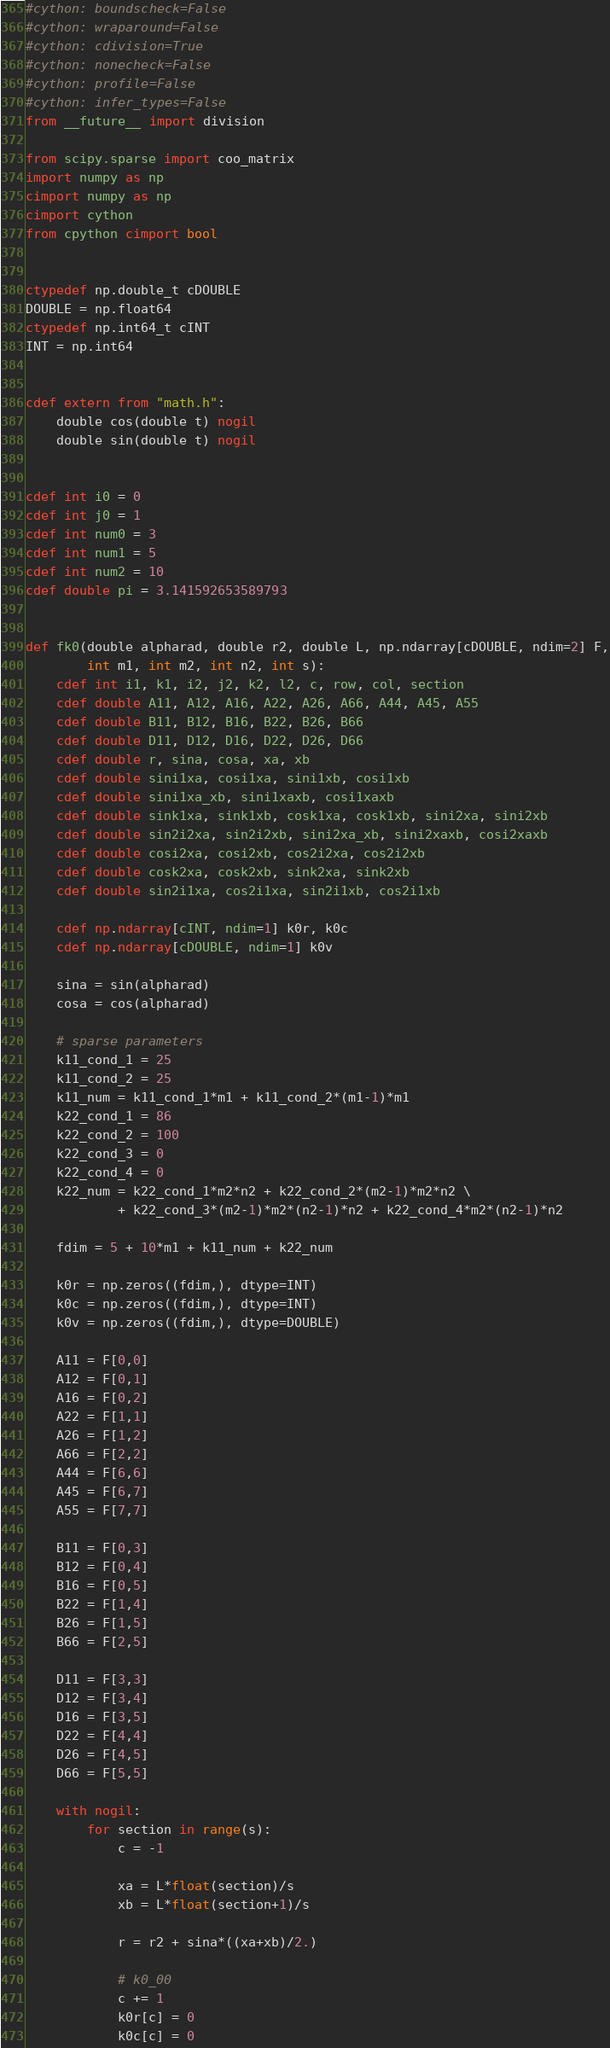Convert code to text. <code><loc_0><loc_0><loc_500><loc_500><_Cython_>#cython: boundscheck=False
#cython: wraparound=False
#cython: cdivision=True
#cython: nonecheck=False
#cython: profile=False
#cython: infer_types=False
from __future__ import division

from scipy.sparse import coo_matrix
import numpy as np
cimport numpy as np
cimport cython
from cpython cimport bool


ctypedef np.double_t cDOUBLE
DOUBLE = np.float64
ctypedef np.int64_t cINT
INT = np.int64


cdef extern from "math.h":
    double cos(double t) nogil
    double sin(double t) nogil


cdef int i0 = 0
cdef int j0 = 1
cdef int num0 = 3
cdef int num1 = 5
cdef int num2 = 10
cdef double pi = 3.141592653589793


def fk0(double alpharad, double r2, double L, np.ndarray[cDOUBLE, ndim=2] F,
        int m1, int m2, int n2, int s):
    cdef int i1, k1, i2, j2, k2, l2, c, row, col, section
    cdef double A11, A12, A16, A22, A26, A66, A44, A45, A55
    cdef double B11, B12, B16, B22, B26, B66
    cdef double D11, D12, D16, D22, D26, D66
    cdef double r, sina, cosa, xa, xb
    cdef double sini1xa, cosi1xa, sini1xb, cosi1xb
    cdef double sini1xa_xb, sini1xaxb, cosi1xaxb
    cdef double sink1xa, sink1xb, cosk1xa, cosk1xb, sini2xa, sini2xb
    cdef double sin2i2xa, sin2i2xb, sini2xa_xb, sini2xaxb, cosi2xaxb
    cdef double cosi2xa, cosi2xb, cos2i2xa, cos2i2xb
    cdef double cosk2xa, cosk2xb, sink2xa, sink2xb
    cdef double sin2i1xa, cos2i1xa, sin2i1xb, cos2i1xb

    cdef np.ndarray[cINT, ndim=1] k0r, k0c
    cdef np.ndarray[cDOUBLE, ndim=1] k0v

    sina = sin(alpharad)
    cosa = cos(alpharad)

    # sparse parameters
    k11_cond_1 = 25
    k11_cond_2 = 25
    k11_num = k11_cond_1*m1 + k11_cond_2*(m1-1)*m1
    k22_cond_1 = 86
    k22_cond_2 = 100
    k22_cond_3 = 0
    k22_cond_4 = 0
    k22_num = k22_cond_1*m2*n2 + k22_cond_2*(m2-1)*m2*n2 \
            + k22_cond_3*(m2-1)*m2*(n2-1)*n2 + k22_cond_4*m2*(n2-1)*n2

    fdim = 5 + 10*m1 + k11_num + k22_num

    k0r = np.zeros((fdim,), dtype=INT)
    k0c = np.zeros((fdim,), dtype=INT)
    k0v = np.zeros((fdim,), dtype=DOUBLE)

    A11 = F[0,0]
    A12 = F[0,1]
    A16 = F[0,2]
    A22 = F[1,1]
    A26 = F[1,2]
    A66 = F[2,2]
    A44 = F[6,6]
    A45 = F[6,7]
    A55 = F[7,7]

    B11 = F[0,3]
    B12 = F[0,4]
    B16 = F[0,5]
    B22 = F[1,4]
    B26 = F[1,5]
    B66 = F[2,5]

    D11 = F[3,3]
    D12 = F[3,4]
    D16 = F[3,5]
    D22 = F[4,4]
    D26 = F[4,5]
    D66 = F[5,5]

    with nogil:
        for section in range(s):
            c = -1

            xa = L*float(section)/s
            xb = L*float(section+1)/s

            r = r2 + sina*((xa+xb)/2.)

            # k0_00
            c += 1
            k0r[c] = 0
            k0c[c] = 0</code> 